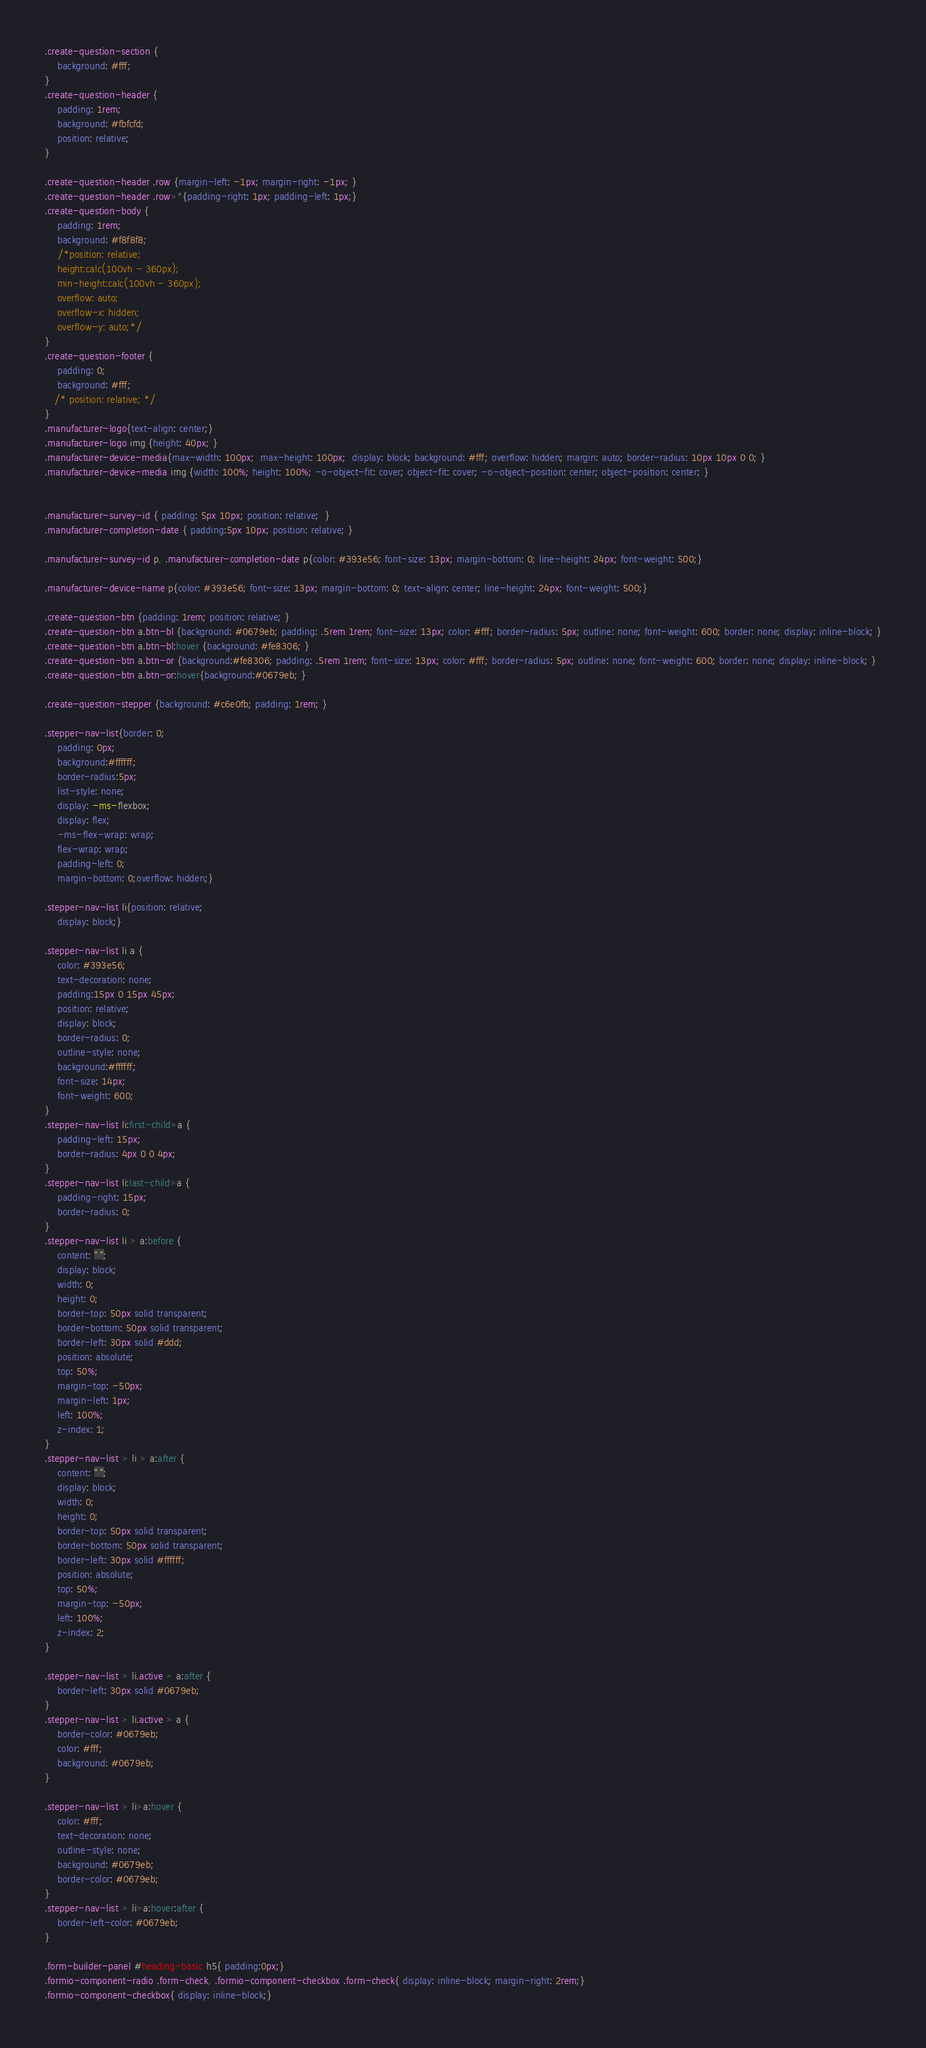<code> <loc_0><loc_0><loc_500><loc_500><_CSS_>.create-question-section {
    background: #fff;
}
.create-question-header {
    padding: 1rem;
    background: #fbfcfd;
    position: relative;
}

.create-question-header .row {margin-left: -1px; margin-right: -1px; }
.create-question-header .row>*{padding-right: 1px; padding-left: 1px;}
.create-question-body {
    padding: 1rem;
    background: #f8f8f8;
    /*position: relative;
    height:calc(100vh - 360px);
    min-height:calc(100vh - 360px);
    overflow: auto;
    overflow-x: hidden;
    overflow-y: auto;*/
}
.create-question-footer {
    padding: 0;
    background: #fff;
   /* position: relative; */
}
.manufacturer-logo{text-align: center;}
.manufacturer-logo img {height: 40px; }
.manufacturer-device-media{max-width: 100px;  max-height: 100px;  display: block; background: #fff; overflow: hidden; margin: auto; border-radius: 10px 10px 0 0; }
.manufacturer-device-media img {width: 100%; height: 100%; -o-object-fit: cover; object-fit: cover; -o-object-position: center; object-position: center; }


.manufacturer-survey-id { padding: 5px 10px; position: relative;  }
.manufacturer-completion-date { padding:5px 10px; position: relative; }

.manufacturer-survey-id p, .manufacturer-completion-date p{color: #393e56; font-size: 13px; margin-bottom: 0; line-height: 24px; font-weight: 500;}

.manufacturer-device-name p{color: #393e56; font-size: 13px; margin-bottom: 0; text-align: center; line-height: 24px; font-weight: 500;}

.create-question-btn {padding: 1rem; position: relative; }
.create-question-btn a.btn-bl {background: #0679eb; padding: .5rem 1rem; font-size: 13px; color: #fff; border-radius: 5px; outline: none; font-weight: 600; border: none; display: inline-block; }
.create-question-btn a.btn-bl:hover {background: #fe8306; }
.create-question-btn a.btn-or {background:#fe8306; padding: .5rem 1rem; font-size: 13px; color: #fff; border-radius: 5px; outline: none; font-weight: 600; border: none; display: inline-block; }
.create-question-btn a.btn-or:hover{background:#0679eb; }

.create-question-stepper {background: #c6e0fb; padding: 1rem; }

.stepper-nav-list{border: 0;
    padding: 0px;
    background:#ffffff;
    border-radius:5px;
    list-style: none;
    display: -ms-flexbox;
    display: flex;
    -ms-flex-wrap: wrap;
    flex-wrap: wrap;
    padding-left: 0;
    margin-bottom: 0;overflow: hidden;}

.stepper-nav-list li{position: relative;
    display: block;}

.stepper-nav-list li a {
    color: #393e56;
    text-decoration: none;
    padding:15px 0 15px 45px;
    position: relative;
    display: block;
    border-radius: 0;
    outline-style: none;
    background:#ffffff;
    font-size: 14px;
    font-weight: 600;
}
.stepper-nav-list li:first-child>a {
    padding-left: 15px;
    border-radius: 4px 0 0 4px;
}
.stepper-nav-list li:last-child>a {
    padding-right: 15px;
    border-radius: 0;
}
.stepper-nav-list li > a:before {
    content: " ";
    display: block;
    width: 0;
    height: 0;
    border-top: 50px solid transparent;
    border-bottom: 50px solid transparent;
    border-left: 30px solid #ddd;
    position: absolute;
    top: 50%;
    margin-top: -50px;
    margin-left: 1px;
    left: 100%;
    z-index: 1;
}
.stepper-nav-list > li > a:after {
    content: " ";
    display: block;
    width: 0;
    height: 0;
    border-top: 50px solid transparent;
    border-bottom: 50px solid transparent;
    border-left: 30px solid #ffffff;
    position: absolute;
    top: 50%;
    margin-top: -50px;
    left: 100%;
    z-index: 2;
}

.stepper-nav-list > li.active > a:after {
    border-left: 30px solid #0679eb;
}
.stepper-nav-list > li.active > a {
    border-color: #0679eb;
    color: #fff;
    background: #0679eb;
}

.stepper-nav-list > li>a:hover {
    color: #fff;
    text-decoration: none;
    outline-style: none;
    background: #0679eb;
    border-color: #0679eb;
}
.stepper-nav-list > li>a:hover:after {
    border-left-color: #0679eb;
}

.form-builder-panel #heading-basic h5{ padding:0px;}
.formio-component-radio .form-check, .formio-component-checkbox .form-check{ display: inline-block; margin-right: 2rem;}
.formio-component-checkbox{ display: inline-block;}</code> 